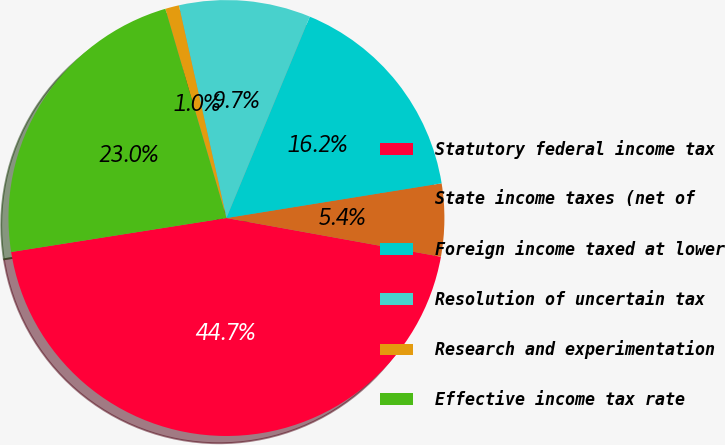<chart> <loc_0><loc_0><loc_500><loc_500><pie_chart><fcel>Statutory federal income tax<fcel>State income taxes (net of<fcel>Foreign income taxed at lower<fcel>Resolution of uncertain tax<fcel>Research and experimentation<fcel>Effective income tax rate<nl><fcel>44.67%<fcel>5.39%<fcel>16.21%<fcel>9.75%<fcel>1.02%<fcel>22.97%<nl></chart> 